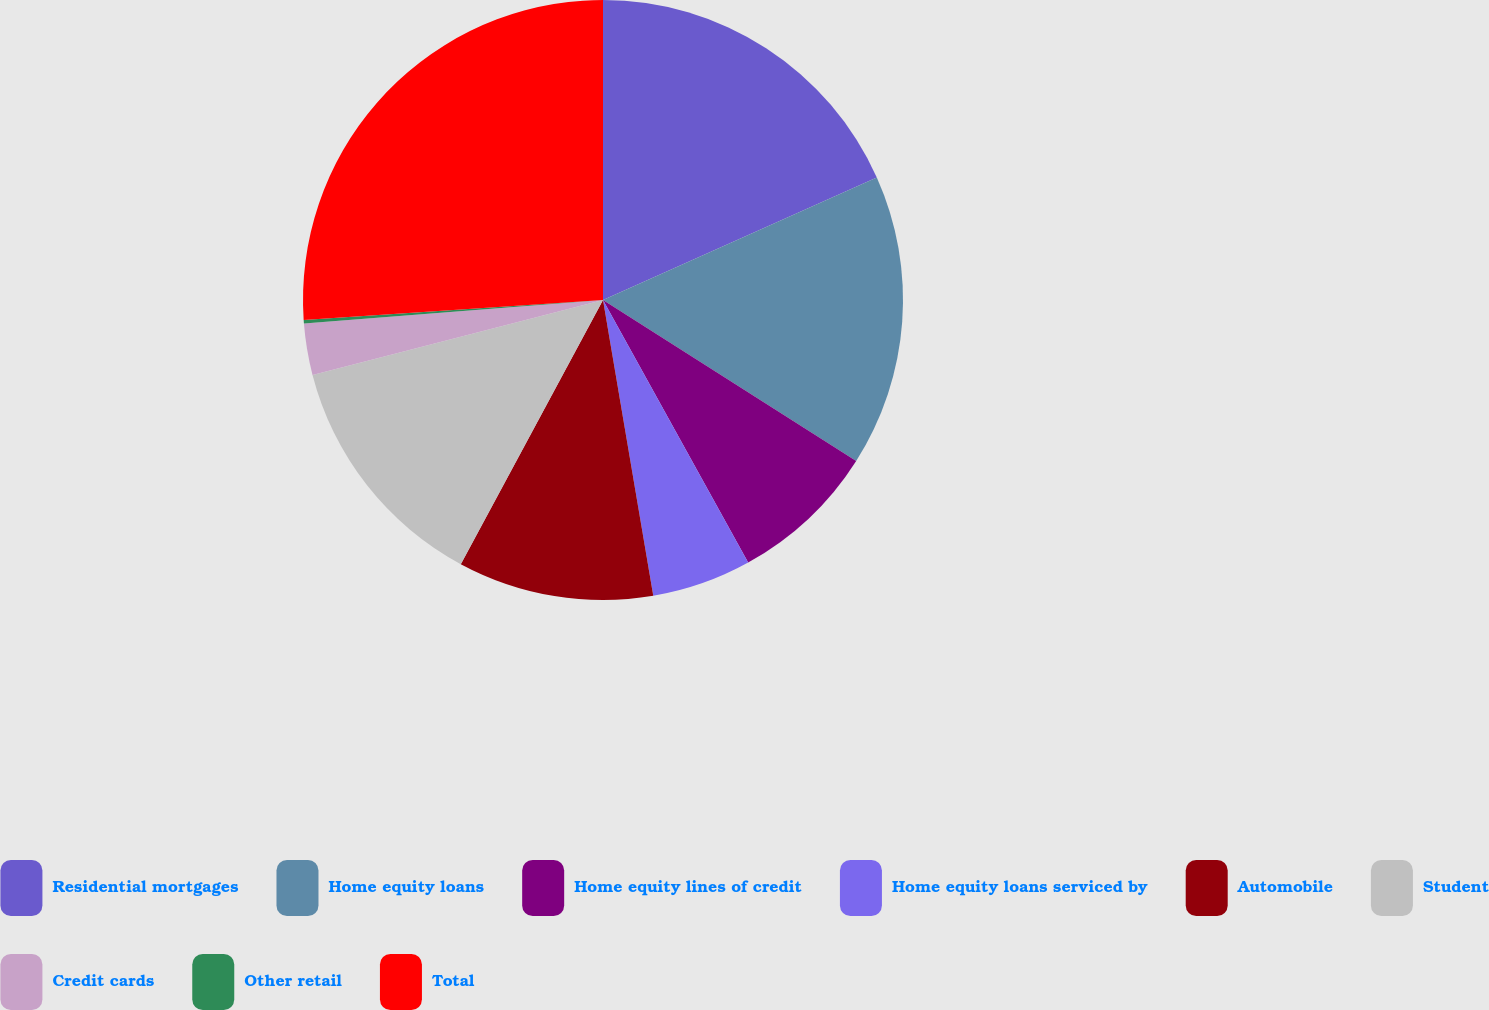<chart> <loc_0><loc_0><loc_500><loc_500><pie_chart><fcel>Residential mortgages<fcel>Home equity loans<fcel>Home equity lines of credit<fcel>Home equity loans serviced by<fcel>Automobile<fcel>Student<fcel>Credit cards<fcel>Other retail<fcel>Total<nl><fcel>18.3%<fcel>15.71%<fcel>7.95%<fcel>5.36%<fcel>10.54%<fcel>13.12%<fcel>2.77%<fcel>0.19%<fcel>26.06%<nl></chart> 